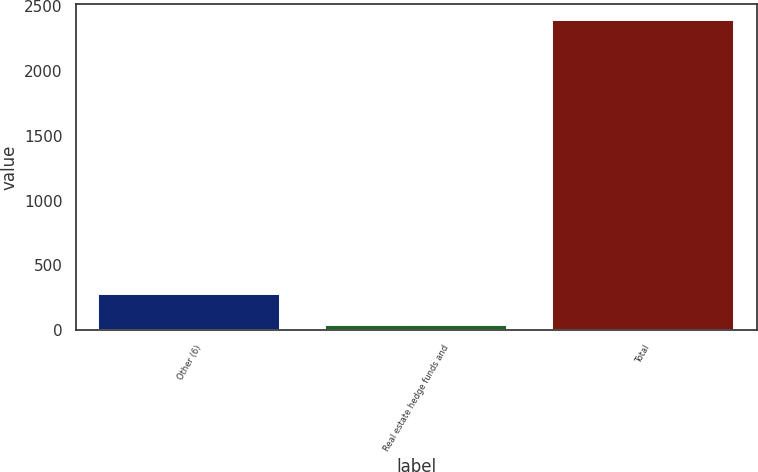Convert chart to OTSL. <chart><loc_0><loc_0><loc_500><loc_500><bar_chart><fcel>Other (6)<fcel>Real estate hedge funds and<fcel>Total<nl><fcel>276.7<fcel>41<fcel>2398<nl></chart> 